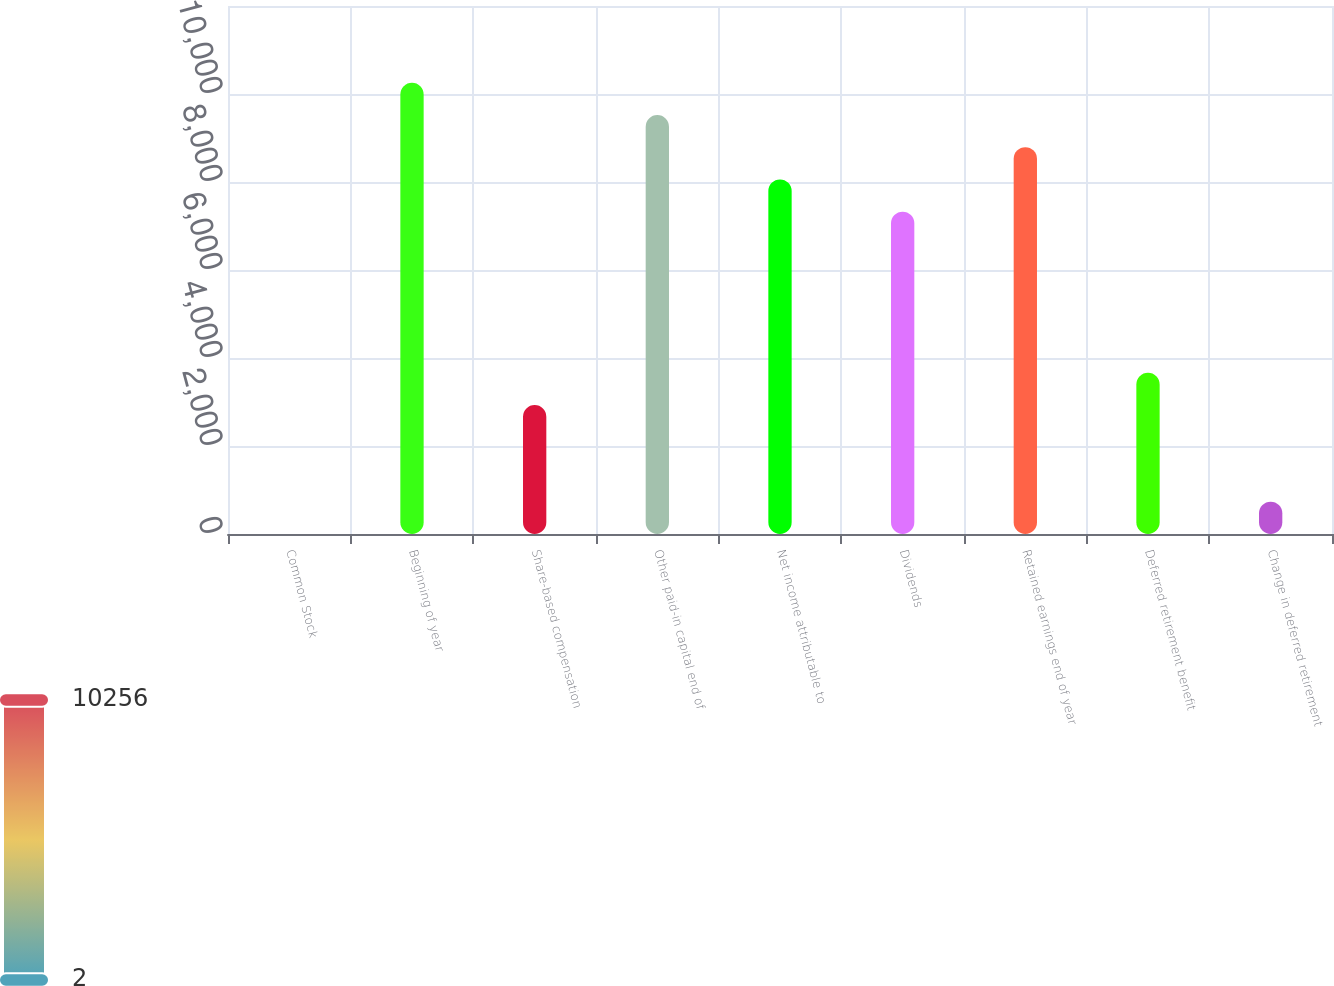<chart> <loc_0><loc_0><loc_500><loc_500><bar_chart><fcel>Common Stock<fcel>Beginning of year<fcel>Share-based compensation<fcel>Other paid-in capital end of<fcel>Net income attributable to<fcel>Dividends<fcel>Retained earnings end of year<fcel>Deferred retirement benefit<fcel>Change in deferred retirement<nl><fcel>2<fcel>10255.6<fcel>2931.6<fcel>9523.2<fcel>8058.4<fcel>7326<fcel>8790.8<fcel>3664<fcel>734.4<nl></chart> 